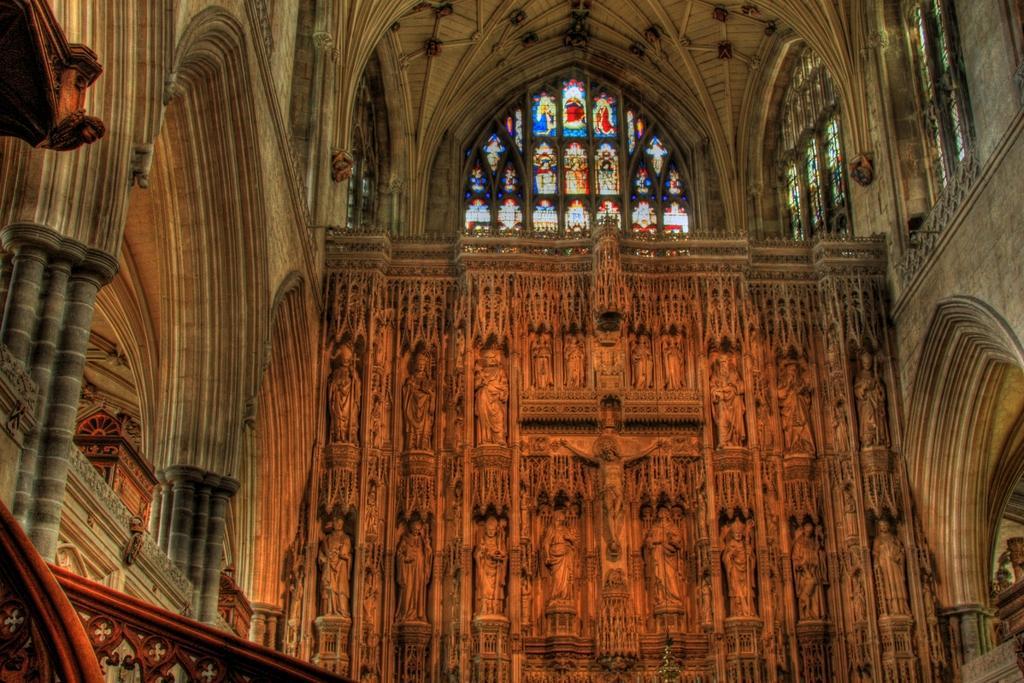How would you summarize this image in a sentence or two? In this picture we can see an inside view of a building, statues, pillars, designs on the window glasses and some objects. 